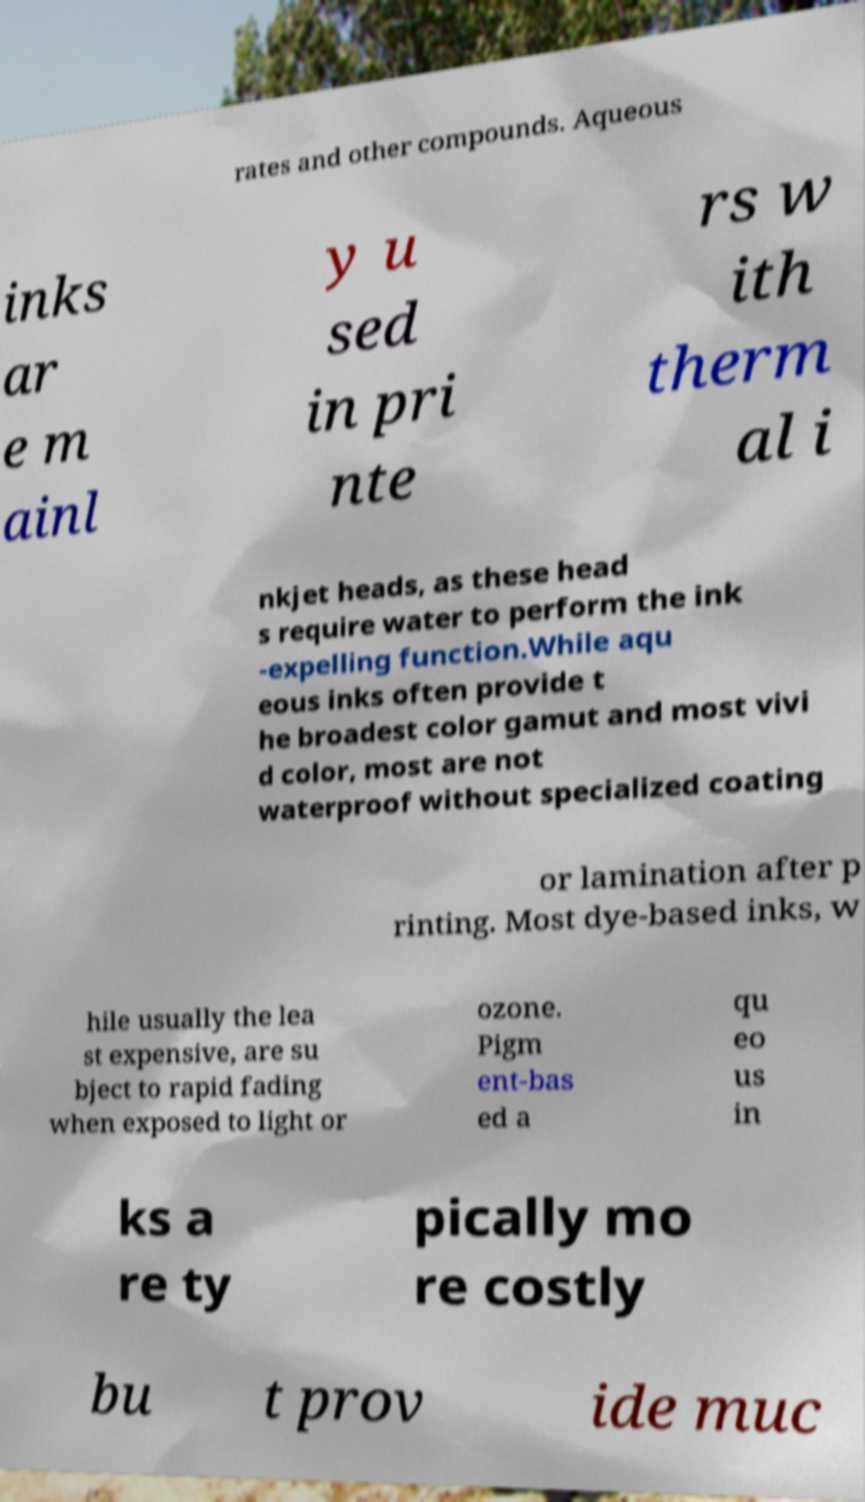Can you accurately transcribe the text from the provided image for me? rates and other compounds. Aqueous inks ar e m ainl y u sed in pri nte rs w ith therm al i nkjet heads, as these head s require water to perform the ink -expelling function.While aqu eous inks often provide t he broadest color gamut and most vivi d color, most are not waterproof without specialized coating or lamination after p rinting. Most dye-based inks, w hile usually the lea st expensive, are su bject to rapid fading when exposed to light or ozone. Pigm ent-bas ed a qu eo us in ks a re ty pically mo re costly bu t prov ide muc 